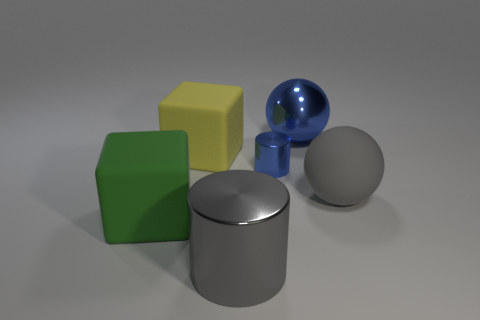How many objects are there, and can you describe their textures? There are five objects in total. Starting from the left, there's a matte yellow cube with a slightly grainy texture, followed by a green matte cube with a smoother appearance. In the center, there’s a cylindrical object with a metallic sheen, indicating a smooth and possibly cold-to-touch texture. Next is a reflective blue sphere, which appears to be quite glossy. Lastly, a grey sphere with a less reflective, matte finish. 